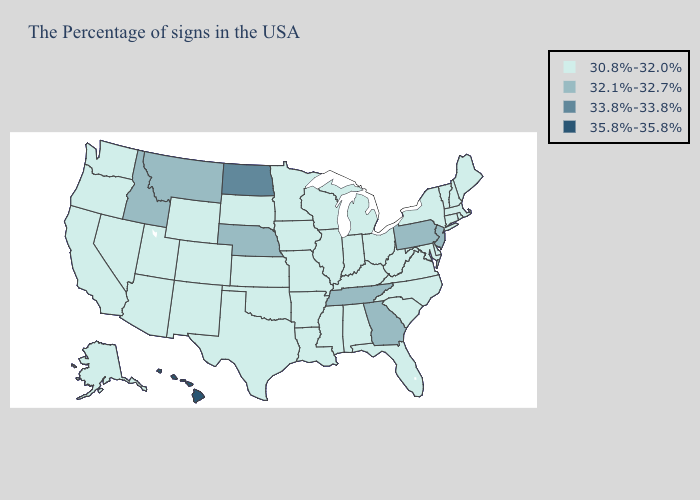Does Tennessee have the lowest value in the South?
Answer briefly. No. Which states have the lowest value in the USA?
Be succinct. Maine, Massachusetts, Rhode Island, New Hampshire, Vermont, Connecticut, New York, Delaware, Maryland, Virginia, North Carolina, South Carolina, West Virginia, Ohio, Florida, Michigan, Kentucky, Indiana, Alabama, Wisconsin, Illinois, Mississippi, Louisiana, Missouri, Arkansas, Minnesota, Iowa, Kansas, Oklahoma, Texas, South Dakota, Wyoming, Colorado, New Mexico, Utah, Arizona, Nevada, California, Washington, Oregon, Alaska. Does North Dakota have the lowest value in the MidWest?
Answer briefly. No. Name the states that have a value in the range 35.8%-35.8%?
Give a very brief answer. Hawaii. Does Hawaii have the highest value in the USA?
Write a very short answer. Yes. Among the states that border Oregon , which have the lowest value?
Be succinct. Nevada, California, Washington. What is the value of Ohio?
Be succinct. 30.8%-32.0%. Does the first symbol in the legend represent the smallest category?
Quick response, please. Yes. Name the states that have a value in the range 32.1%-32.7%?
Short answer required. New Jersey, Pennsylvania, Georgia, Tennessee, Nebraska, Montana, Idaho. What is the value of Connecticut?
Concise answer only. 30.8%-32.0%. Name the states that have a value in the range 33.8%-33.8%?
Quick response, please. North Dakota. Name the states that have a value in the range 30.8%-32.0%?
Short answer required. Maine, Massachusetts, Rhode Island, New Hampshire, Vermont, Connecticut, New York, Delaware, Maryland, Virginia, North Carolina, South Carolina, West Virginia, Ohio, Florida, Michigan, Kentucky, Indiana, Alabama, Wisconsin, Illinois, Mississippi, Louisiana, Missouri, Arkansas, Minnesota, Iowa, Kansas, Oklahoma, Texas, South Dakota, Wyoming, Colorado, New Mexico, Utah, Arizona, Nevada, California, Washington, Oregon, Alaska. Among the states that border North Carolina , which have the highest value?
Concise answer only. Georgia, Tennessee. Name the states that have a value in the range 35.8%-35.8%?
Be succinct. Hawaii. What is the lowest value in the USA?
Answer briefly. 30.8%-32.0%. 